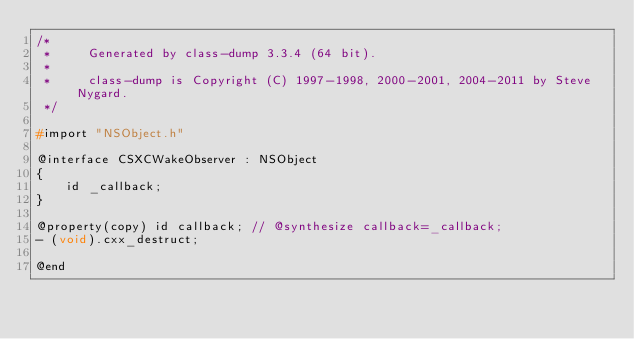<code> <loc_0><loc_0><loc_500><loc_500><_C_>/*
 *     Generated by class-dump 3.3.4 (64 bit).
 *
 *     class-dump is Copyright (C) 1997-1998, 2000-2001, 2004-2011 by Steve Nygard.
 */

#import "NSObject.h"

@interface CSXCWakeObserver : NSObject
{
    id _callback;
}

@property(copy) id callback; // @synthesize callback=_callback;
- (void).cxx_destruct;

@end

</code> 